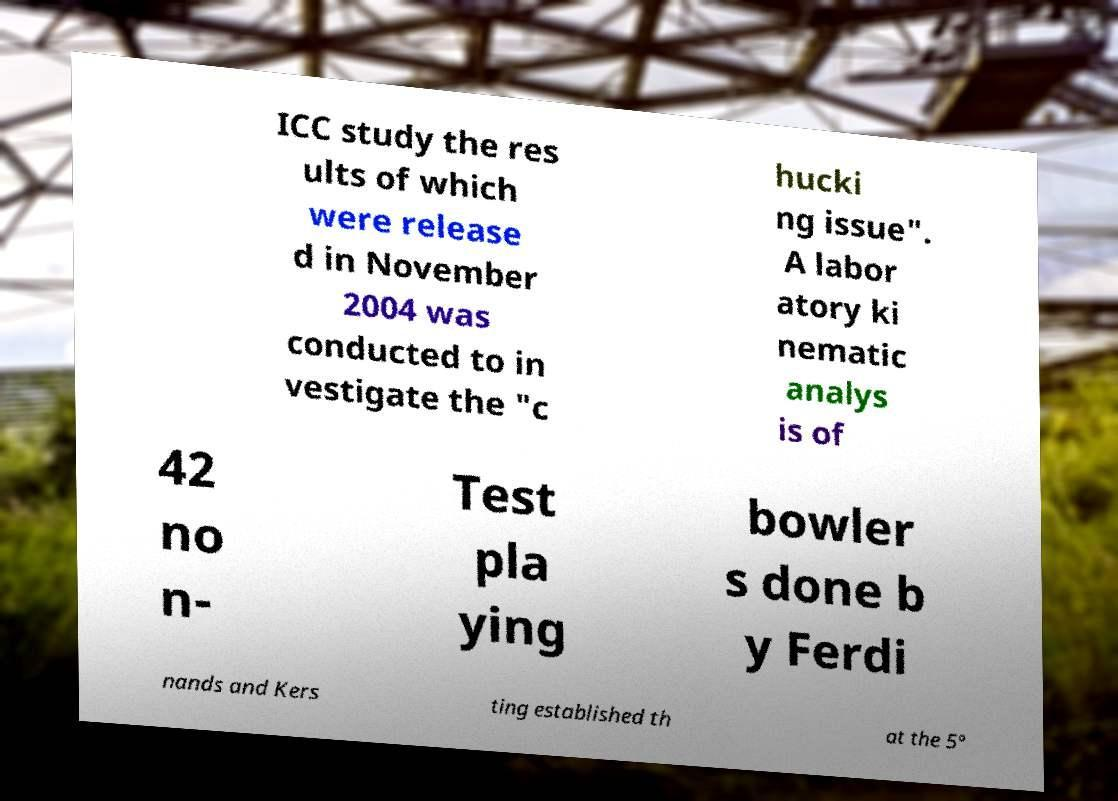I need the written content from this picture converted into text. Can you do that? ICC study the res ults of which were release d in November 2004 was conducted to in vestigate the "c hucki ng issue". A labor atory ki nematic analys is of 42 no n- Test pla ying bowler s done b y Ferdi nands and Kers ting established th at the 5° 